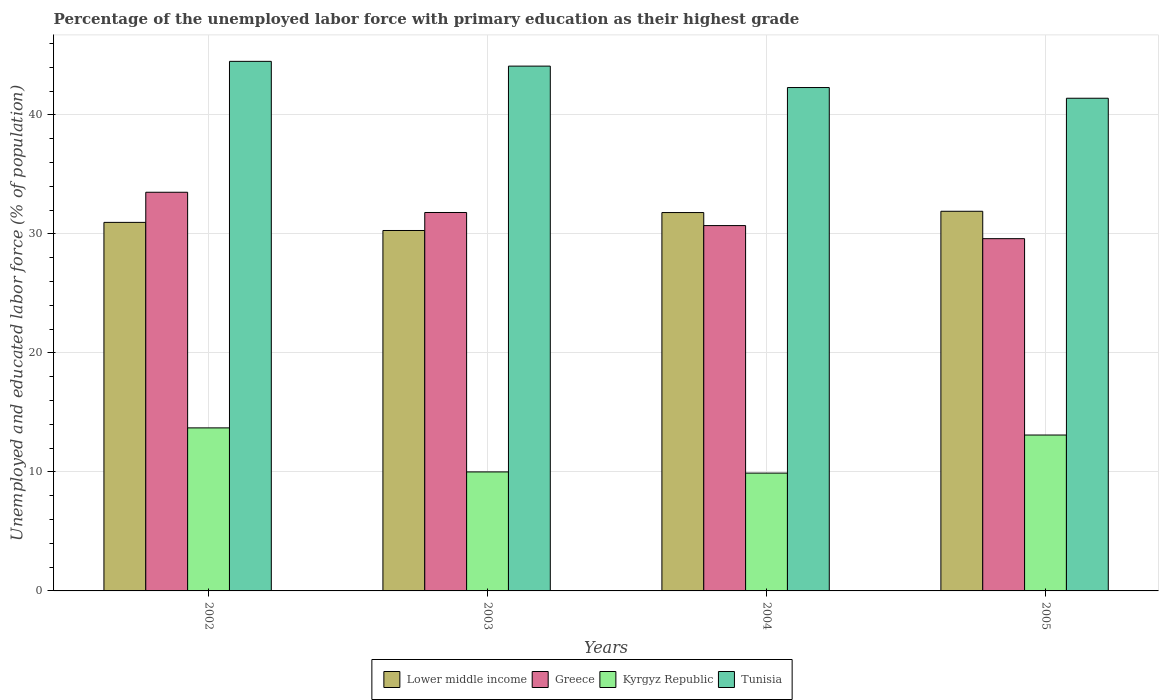How many different coloured bars are there?
Your answer should be compact. 4. Are the number of bars per tick equal to the number of legend labels?
Keep it short and to the point. Yes. Are the number of bars on each tick of the X-axis equal?
Keep it short and to the point. Yes. How many bars are there on the 3rd tick from the left?
Your response must be concise. 4. How many bars are there on the 2nd tick from the right?
Offer a very short reply. 4. What is the percentage of the unemployed labor force with primary education in Lower middle income in 2004?
Keep it short and to the point. 31.79. Across all years, what is the maximum percentage of the unemployed labor force with primary education in Lower middle income?
Offer a very short reply. 31.9. Across all years, what is the minimum percentage of the unemployed labor force with primary education in Kyrgyz Republic?
Offer a terse response. 9.9. In which year was the percentage of the unemployed labor force with primary education in Greece minimum?
Your answer should be very brief. 2005. What is the total percentage of the unemployed labor force with primary education in Tunisia in the graph?
Provide a succinct answer. 172.3. What is the difference between the percentage of the unemployed labor force with primary education in Greece in 2003 and that in 2004?
Offer a very short reply. 1.1. What is the difference between the percentage of the unemployed labor force with primary education in Greece in 2005 and the percentage of the unemployed labor force with primary education in Lower middle income in 2003?
Make the answer very short. -0.69. What is the average percentage of the unemployed labor force with primary education in Lower middle income per year?
Your response must be concise. 31.24. In the year 2005, what is the difference between the percentage of the unemployed labor force with primary education in Lower middle income and percentage of the unemployed labor force with primary education in Tunisia?
Your answer should be very brief. -9.5. What is the ratio of the percentage of the unemployed labor force with primary education in Kyrgyz Republic in 2002 to that in 2004?
Your answer should be compact. 1.38. Is the percentage of the unemployed labor force with primary education in Kyrgyz Republic in 2003 less than that in 2004?
Provide a succinct answer. No. What is the difference between the highest and the second highest percentage of the unemployed labor force with primary education in Greece?
Keep it short and to the point. 1.7. What is the difference between the highest and the lowest percentage of the unemployed labor force with primary education in Lower middle income?
Provide a short and direct response. 1.62. What does the 1st bar from the left in 2003 represents?
Make the answer very short. Lower middle income. What does the 4th bar from the right in 2004 represents?
Keep it short and to the point. Lower middle income. How many bars are there?
Give a very brief answer. 16. What is the difference between two consecutive major ticks on the Y-axis?
Ensure brevity in your answer.  10. Are the values on the major ticks of Y-axis written in scientific E-notation?
Offer a terse response. No. Does the graph contain grids?
Offer a very short reply. Yes. Where does the legend appear in the graph?
Keep it short and to the point. Bottom center. What is the title of the graph?
Offer a very short reply. Percentage of the unemployed labor force with primary education as their highest grade. Does "Albania" appear as one of the legend labels in the graph?
Offer a terse response. No. What is the label or title of the X-axis?
Keep it short and to the point. Years. What is the label or title of the Y-axis?
Your answer should be compact. Unemployed and educated labor force (% of population). What is the Unemployed and educated labor force (% of population) of Lower middle income in 2002?
Your response must be concise. 30.97. What is the Unemployed and educated labor force (% of population) in Greece in 2002?
Make the answer very short. 33.5. What is the Unemployed and educated labor force (% of population) in Kyrgyz Republic in 2002?
Give a very brief answer. 13.7. What is the Unemployed and educated labor force (% of population) in Tunisia in 2002?
Make the answer very short. 44.5. What is the Unemployed and educated labor force (% of population) in Lower middle income in 2003?
Your answer should be very brief. 30.29. What is the Unemployed and educated labor force (% of population) of Greece in 2003?
Provide a succinct answer. 31.8. What is the Unemployed and educated labor force (% of population) of Kyrgyz Republic in 2003?
Offer a terse response. 10. What is the Unemployed and educated labor force (% of population) of Tunisia in 2003?
Keep it short and to the point. 44.1. What is the Unemployed and educated labor force (% of population) of Lower middle income in 2004?
Your response must be concise. 31.79. What is the Unemployed and educated labor force (% of population) of Greece in 2004?
Offer a terse response. 30.7. What is the Unemployed and educated labor force (% of population) of Kyrgyz Republic in 2004?
Give a very brief answer. 9.9. What is the Unemployed and educated labor force (% of population) in Tunisia in 2004?
Make the answer very short. 42.3. What is the Unemployed and educated labor force (% of population) of Lower middle income in 2005?
Your answer should be very brief. 31.9. What is the Unemployed and educated labor force (% of population) of Greece in 2005?
Make the answer very short. 29.6. What is the Unemployed and educated labor force (% of population) in Kyrgyz Republic in 2005?
Provide a succinct answer. 13.1. What is the Unemployed and educated labor force (% of population) of Tunisia in 2005?
Make the answer very short. 41.4. Across all years, what is the maximum Unemployed and educated labor force (% of population) in Lower middle income?
Your response must be concise. 31.9. Across all years, what is the maximum Unemployed and educated labor force (% of population) in Greece?
Give a very brief answer. 33.5. Across all years, what is the maximum Unemployed and educated labor force (% of population) of Kyrgyz Republic?
Your answer should be compact. 13.7. Across all years, what is the maximum Unemployed and educated labor force (% of population) in Tunisia?
Make the answer very short. 44.5. Across all years, what is the minimum Unemployed and educated labor force (% of population) of Lower middle income?
Ensure brevity in your answer.  30.29. Across all years, what is the minimum Unemployed and educated labor force (% of population) of Greece?
Provide a succinct answer. 29.6. Across all years, what is the minimum Unemployed and educated labor force (% of population) in Kyrgyz Republic?
Provide a short and direct response. 9.9. Across all years, what is the minimum Unemployed and educated labor force (% of population) of Tunisia?
Provide a succinct answer. 41.4. What is the total Unemployed and educated labor force (% of population) in Lower middle income in the graph?
Provide a short and direct response. 124.95. What is the total Unemployed and educated labor force (% of population) in Greece in the graph?
Ensure brevity in your answer.  125.6. What is the total Unemployed and educated labor force (% of population) of Kyrgyz Republic in the graph?
Make the answer very short. 46.7. What is the total Unemployed and educated labor force (% of population) in Tunisia in the graph?
Your answer should be very brief. 172.3. What is the difference between the Unemployed and educated labor force (% of population) in Lower middle income in 2002 and that in 2003?
Give a very brief answer. 0.68. What is the difference between the Unemployed and educated labor force (% of population) of Tunisia in 2002 and that in 2003?
Give a very brief answer. 0.4. What is the difference between the Unemployed and educated labor force (% of population) in Lower middle income in 2002 and that in 2004?
Provide a short and direct response. -0.83. What is the difference between the Unemployed and educated labor force (% of population) in Lower middle income in 2002 and that in 2005?
Offer a very short reply. -0.93. What is the difference between the Unemployed and educated labor force (% of population) in Greece in 2002 and that in 2005?
Give a very brief answer. 3.9. What is the difference between the Unemployed and educated labor force (% of population) of Kyrgyz Republic in 2002 and that in 2005?
Ensure brevity in your answer.  0.6. What is the difference between the Unemployed and educated labor force (% of population) in Lower middle income in 2003 and that in 2004?
Ensure brevity in your answer.  -1.51. What is the difference between the Unemployed and educated labor force (% of population) of Greece in 2003 and that in 2004?
Offer a terse response. 1.1. What is the difference between the Unemployed and educated labor force (% of population) of Kyrgyz Republic in 2003 and that in 2004?
Make the answer very short. 0.1. What is the difference between the Unemployed and educated labor force (% of population) of Tunisia in 2003 and that in 2004?
Your answer should be very brief. 1.8. What is the difference between the Unemployed and educated labor force (% of population) in Lower middle income in 2003 and that in 2005?
Ensure brevity in your answer.  -1.62. What is the difference between the Unemployed and educated labor force (% of population) of Greece in 2003 and that in 2005?
Your answer should be compact. 2.2. What is the difference between the Unemployed and educated labor force (% of population) of Lower middle income in 2004 and that in 2005?
Give a very brief answer. -0.11. What is the difference between the Unemployed and educated labor force (% of population) of Tunisia in 2004 and that in 2005?
Your answer should be compact. 0.9. What is the difference between the Unemployed and educated labor force (% of population) in Lower middle income in 2002 and the Unemployed and educated labor force (% of population) in Greece in 2003?
Keep it short and to the point. -0.83. What is the difference between the Unemployed and educated labor force (% of population) of Lower middle income in 2002 and the Unemployed and educated labor force (% of population) of Kyrgyz Republic in 2003?
Provide a short and direct response. 20.97. What is the difference between the Unemployed and educated labor force (% of population) in Lower middle income in 2002 and the Unemployed and educated labor force (% of population) in Tunisia in 2003?
Ensure brevity in your answer.  -13.13. What is the difference between the Unemployed and educated labor force (% of population) in Greece in 2002 and the Unemployed and educated labor force (% of population) in Kyrgyz Republic in 2003?
Your response must be concise. 23.5. What is the difference between the Unemployed and educated labor force (% of population) in Greece in 2002 and the Unemployed and educated labor force (% of population) in Tunisia in 2003?
Make the answer very short. -10.6. What is the difference between the Unemployed and educated labor force (% of population) in Kyrgyz Republic in 2002 and the Unemployed and educated labor force (% of population) in Tunisia in 2003?
Your answer should be very brief. -30.4. What is the difference between the Unemployed and educated labor force (% of population) in Lower middle income in 2002 and the Unemployed and educated labor force (% of population) in Greece in 2004?
Provide a short and direct response. 0.27. What is the difference between the Unemployed and educated labor force (% of population) in Lower middle income in 2002 and the Unemployed and educated labor force (% of population) in Kyrgyz Republic in 2004?
Keep it short and to the point. 21.07. What is the difference between the Unemployed and educated labor force (% of population) in Lower middle income in 2002 and the Unemployed and educated labor force (% of population) in Tunisia in 2004?
Give a very brief answer. -11.33. What is the difference between the Unemployed and educated labor force (% of population) in Greece in 2002 and the Unemployed and educated labor force (% of population) in Kyrgyz Republic in 2004?
Your answer should be compact. 23.6. What is the difference between the Unemployed and educated labor force (% of population) of Kyrgyz Republic in 2002 and the Unemployed and educated labor force (% of population) of Tunisia in 2004?
Offer a terse response. -28.6. What is the difference between the Unemployed and educated labor force (% of population) of Lower middle income in 2002 and the Unemployed and educated labor force (% of population) of Greece in 2005?
Give a very brief answer. 1.37. What is the difference between the Unemployed and educated labor force (% of population) of Lower middle income in 2002 and the Unemployed and educated labor force (% of population) of Kyrgyz Republic in 2005?
Keep it short and to the point. 17.87. What is the difference between the Unemployed and educated labor force (% of population) in Lower middle income in 2002 and the Unemployed and educated labor force (% of population) in Tunisia in 2005?
Offer a very short reply. -10.43. What is the difference between the Unemployed and educated labor force (% of population) of Greece in 2002 and the Unemployed and educated labor force (% of population) of Kyrgyz Republic in 2005?
Your response must be concise. 20.4. What is the difference between the Unemployed and educated labor force (% of population) of Kyrgyz Republic in 2002 and the Unemployed and educated labor force (% of population) of Tunisia in 2005?
Provide a succinct answer. -27.7. What is the difference between the Unemployed and educated labor force (% of population) in Lower middle income in 2003 and the Unemployed and educated labor force (% of population) in Greece in 2004?
Ensure brevity in your answer.  -0.41. What is the difference between the Unemployed and educated labor force (% of population) of Lower middle income in 2003 and the Unemployed and educated labor force (% of population) of Kyrgyz Republic in 2004?
Provide a short and direct response. 20.39. What is the difference between the Unemployed and educated labor force (% of population) in Lower middle income in 2003 and the Unemployed and educated labor force (% of population) in Tunisia in 2004?
Provide a short and direct response. -12.01. What is the difference between the Unemployed and educated labor force (% of population) in Greece in 2003 and the Unemployed and educated labor force (% of population) in Kyrgyz Republic in 2004?
Your response must be concise. 21.9. What is the difference between the Unemployed and educated labor force (% of population) of Greece in 2003 and the Unemployed and educated labor force (% of population) of Tunisia in 2004?
Your answer should be compact. -10.5. What is the difference between the Unemployed and educated labor force (% of population) in Kyrgyz Republic in 2003 and the Unemployed and educated labor force (% of population) in Tunisia in 2004?
Your response must be concise. -32.3. What is the difference between the Unemployed and educated labor force (% of population) in Lower middle income in 2003 and the Unemployed and educated labor force (% of population) in Greece in 2005?
Your answer should be compact. 0.69. What is the difference between the Unemployed and educated labor force (% of population) of Lower middle income in 2003 and the Unemployed and educated labor force (% of population) of Kyrgyz Republic in 2005?
Provide a short and direct response. 17.19. What is the difference between the Unemployed and educated labor force (% of population) of Lower middle income in 2003 and the Unemployed and educated labor force (% of population) of Tunisia in 2005?
Provide a succinct answer. -11.11. What is the difference between the Unemployed and educated labor force (% of population) in Greece in 2003 and the Unemployed and educated labor force (% of population) in Kyrgyz Republic in 2005?
Give a very brief answer. 18.7. What is the difference between the Unemployed and educated labor force (% of population) of Greece in 2003 and the Unemployed and educated labor force (% of population) of Tunisia in 2005?
Give a very brief answer. -9.6. What is the difference between the Unemployed and educated labor force (% of population) in Kyrgyz Republic in 2003 and the Unemployed and educated labor force (% of population) in Tunisia in 2005?
Keep it short and to the point. -31.4. What is the difference between the Unemployed and educated labor force (% of population) of Lower middle income in 2004 and the Unemployed and educated labor force (% of population) of Greece in 2005?
Make the answer very short. 2.19. What is the difference between the Unemployed and educated labor force (% of population) of Lower middle income in 2004 and the Unemployed and educated labor force (% of population) of Kyrgyz Republic in 2005?
Offer a very short reply. 18.69. What is the difference between the Unemployed and educated labor force (% of population) in Lower middle income in 2004 and the Unemployed and educated labor force (% of population) in Tunisia in 2005?
Your response must be concise. -9.61. What is the difference between the Unemployed and educated labor force (% of population) of Greece in 2004 and the Unemployed and educated labor force (% of population) of Kyrgyz Republic in 2005?
Ensure brevity in your answer.  17.6. What is the difference between the Unemployed and educated labor force (% of population) of Greece in 2004 and the Unemployed and educated labor force (% of population) of Tunisia in 2005?
Your answer should be compact. -10.7. What is the difference between the Unemployed and educated labor force (% of population) in Kyrgyz Republic in 2004 and the Unemployed and educated labor force (% of population) in Tunisia in 2005?
Your answer should be compact. -31.5. What is the average Unemployed and educated labor force (% of population) in Lower middle income per year?
Offer a very short reply. 31.24. What is the average Unemployed and educated labor force (% of population) in Greece per year?
Ensure brevity in your answer.  31.4. What is the average Unemployed and educated labor force (% of population) of Kyrgyz Republic per year?
Offer a terse response. 11.68. What is the average Unemployed and educated labor force (% of population) of Tunisia per year?
Your answer should be very brief. 43.08. In the year 2002, what is the difference between the Unemployed and educated labor force (% of population) of Lower middle income and Unemployed and educated labor force (% of population) of Greece?
Your response must be concise. -2.53. In the year 2002, what is the difference between the Unemployed and educated labor force (% of population) of Lower middle income and Unemployed and educated labor force (% of population) of Kyrgyz Republic?
Ensure brevity in your answer.  17.27. In the year 2002, what is the difference between the Unemployed and educated labor force (% of population) in Lower middle income and Unemployed and educated labor force (% of population) in Tunisia?
Your answer should be very brief. -13.53. In the year 2002, what is the difference between the Unemployed and educated labor force (% of population) of Greece and Unemployed and educated labor force (% of population) of Kyrgyz Republic?
Provide a short and direct response. 19.8. In the year 2002, what is the difference between the Unemployed and educated labor force (% of population) in Greece and Unemployed and educated labor force (% of population) in Tunisia?
Provide a succinct answer. -11. In the year 2002, what is the difference between the Unemployed and educated labor force (% of population) in Kyrgyz Republic and Unemployed and educated labor force (% of population) in Tunisia?
Provide a succinct answer. -30.8. In the year 2003, what is the difference between the Unemployed and educated labor force (% of population) of Lower middle income and Unemployed and educated labor force (% of population) of Greece?
Give a very brief answer. -1.51. In the year 2003, what is the difference between the Unemployed and educated labor force (% of population) in Lower middle income and Unemployed and educated labor force (% of population) in Kyrgyz Republic?
Your response must be concise. 20.29. In the year 2003, what is the difference between the Unemployed and educated labor force (% of population) of Lower middle income and Unemployed and educated labor force (% of population) of Tunisia?
Your response must be concise. -13.81. In the year 2003, what is the difference between the Unemployed and educated labor force (% of population) in Greece and Unemployed and educated labor force (% of population) in Kyrgyz Republic?
Provide a short and direct response. 21.8. In the year 2003, what is the difference between the Unemployed and educated labor force (% of population) of Greece and Unemployed and educated labor force (% of population) of Tunisia?
Give a very brief answer. -12.3. In the year 2003, what is the difference between the Unemployed and educated labor force (% of population) in Kyrgyz Republic and Unemployed and educated labor force (% of population) in Tunisia?
Keep it short and to the point. -34.1. In the year 2004, what is the difference between the Unemployed and educated labor force (% of population) of Lower middle income and Unemployed and educated labor force (% of population) of Greece?
Keep it short and to the point. 1.09. In the year 2004, what is the difference between the Unemployed and educated labor force (% of population) of Lower middle income and Unemployed and educated labor force (% of population) of Kyrgyz Republic?
Your answer should be very brief. 21.89. In the year 2004, what is the difference between the Unemployed and educated labor force (% of population) in Lower middle income and Unemployed and educated labor force (% of population) in Tunisia?
Your response must be concise. -10.51. In the year 2004, what is the difference between the Unemployed and educated labor force (% of population) of Greece and Unemployed and educated labor force (% of population) of Kyrgyz Republic?
Make the answer very short. 20.8. In the year 2004, what is the difference between the Unemployed and educated labor force (% of population) in Kyrgyz Republic and Unemployed and educated labor force (% of population) in Tunisia?
Make the answer very short. -32.4. In the year 2005, what is the difference between the Unemployed and educated labor force (% of population) of Lower middle income and Unemployed and educated labor force (% of population) of Greece?
Provide a succinct answer. 2.3. In the year 2005, what is the difference between the Unemployed and educated labor force (% of population) of Lower middle income and Unemployed and educated labor force (% of population) of Kyrgyz Republic?
Make the answer very short. 18.8. In the year 2005, what is the difference between the Unemployed and educated labor force (% of population) of Lower middle income and Unemployed and educated labor force (% of population) of Tunisia?
Give a very brief answer. -9.5. In the year 2005, what is the difference between the Unemployed and educated labor force (% of population) in Greece and Unemployed and educated labor force (% of population) in Tunisia?
Your response must be concise. -11.8. In the year 2005, what is the difference between the Unemployed and educated labor force (% of population) in Kyrgyz Republic and Unemployed and educated labor force (% of population) in Tunisia?
Provide a short and direct response. -28.3. What is the ratio of the Unemployed and educated labor force (% of population) of Lower middle income in 2002 to that in 2003?
Offer a very short reply. 1.02. What is the ratio of the Unemployed and educated labor force (% of population) in Greece in 2002 to that in 2003?
Give a very brief answer. 1.05. What is the ratio of the Unemployed and educated labor force (% of population) in Kyrgyz Republic in 2002 to that in 2003?
Keep it short and to the point. 1.37. What is the ratio of the Unemployed and educated labor force (% of population) in Tunisia in 2002 to that in 2003?
Keep it short and to the point. 1.01. What is the ratio of the Unemployed and educated labor force (% of population) in Greece in 2002 to that in 2004?
Your response must be concise. 1.09. What is the ratio of the Unemployed and educated labor force (% of population) in Kyrgyz Republic in 2002 to that in 2004?
Provide a succinct answer. 1.38. What is the ratio of the Unemployed and educated labor force (% of population) of Tunisia in 2002 to that in 2004?
Give a very brief answer. 1.05. What is the ratio of the Unemployed and educated labor force (% of population) of Lower middle income in 2002 to that in 2005?
Ensure brevity in your answer.  0.97. What is the ratio of the Unemployed and educated labor force (% of population) of Greece in 2002 to that in 2005?
Give a very brief answer. 1.13. What is the ratio of the Unemployed and educated labor force (% of population) of Kyrgyz Republic in 2002 to that in 2005?
Make the answer very short. 1.05. What is the ratio of the Unemployed and educated labor force (% of population) in Tunisia in 2002 to that in 2005?
Keep it short and to the point. 1.07. What is the ratio of the Unemployed and educated labor force (% of population) in Lower middle income in 2003 to that in 2004?
Offer a terse response. 0.95. What is the ratio of the Unemployed and educated labor force (% of population) of Greece in 2003 to that in 2004?
Provide a short and direct response. 1.04. What is the ratio of the Unemployed and educated labor force (% of population) of Tunisia in 2003 to that in 2004?
Keep it short and to the point. 1.04. What is the ratio of the Unemployed and educated labor force (% of population) of Lower middle income in 2003 to that in 2005?
Give a very brief answer. 0.95. What is the ratio of the Unemployed and educated labor force (% of population) in Greece in 2003 to that in 2005?
Your response must be concise. 1.07. What is the ratio of the Unemployed and educated labor force (% of population) of Kyrgyz Republic in 2003 to that in 2005?
Offer a terse response. 0.76. What is the ratio of the Unemployed and educated labor force (% of population) in Tunisia in 2003 to that in 2005?
Provide a succinct answer. 1.07. What is the ratio of the Unemployed and educated labor force (% of population) of Greece in 2004 to that in 2005?
Offer a terse response. 1.04. What is the ratio of the Unemployed and educated labor force (% of population) in Kyrgyz Republic in 2004 to that in 2005?
Offer a terse response. 0.76. What is the ratio of the Unemployed and educated labor force (% of population) of Tunisia in 2004 to that in 2005?
Ensure brevity in your answer.  1.02. What is the difference between the highest and the second highest Unemployed and educated labor force (% of population) in Lower middle income?
Offer a terse response. 0.11. What is the difference between the highest and the second highest Unemployed and educated labor force (% of population) of Greece?
Offer a very short reply. 1.7. What is the difference between the highest and the second highest Unemployed and educated labor force (% of population) of Tunisia?
Provide a succinct answer. 0.4. What is the difference between the highest and the lowest Unemployed and educated labor force (% of population) of Lower middle income?
Ensure brevity in your answer.  1.62. What is the difference between the highest and the lowest Unemployed and educated labor force (% of population) in Greece?
Keep it short and to the point. 3.9. What is the difference between the highest and the lowest Unemployed and educated labor force (% of population) of Kyrgyz Republic?
Your response must be concise. 3.8. What is the difference between the highest and the lowest Unemployed and educated labor force (% of population) in Tunisia?
Offer a terse response. 3.1. 